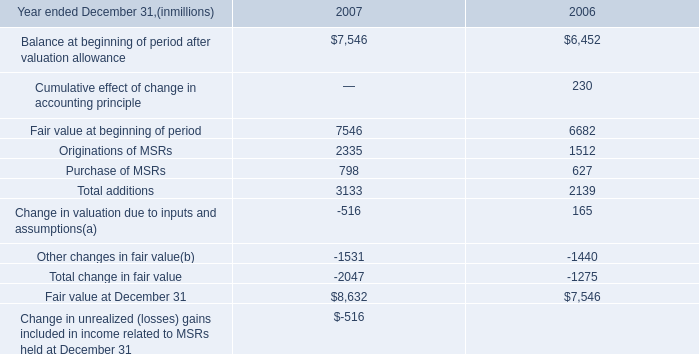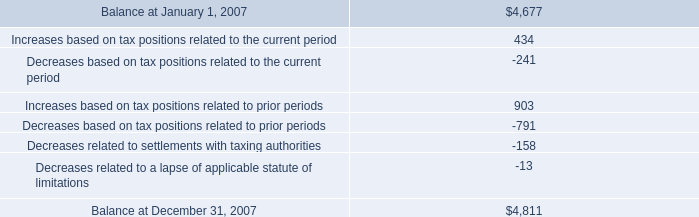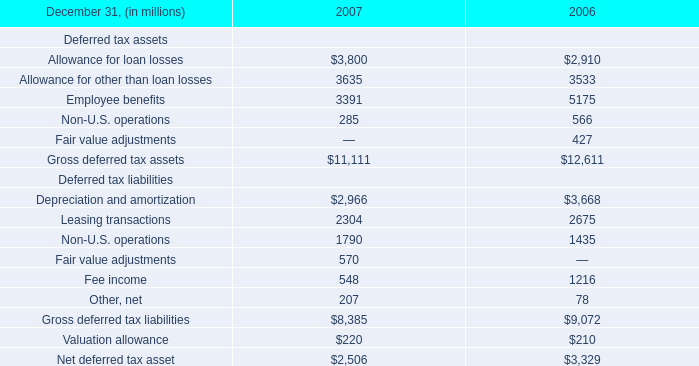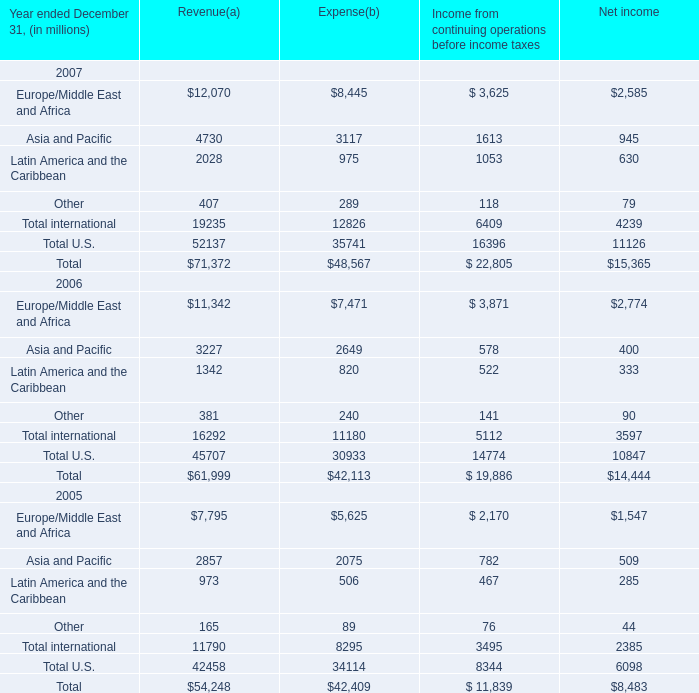What is the sum of Allowance for other than loan losses of 2006, Europe/Middle East and Africa 2006 of Net income, and Other changes in fair value of 2006 ? 
Computations: ((3533.0 + 2774.0) + 1440.0)
Answer: 7747.0. 